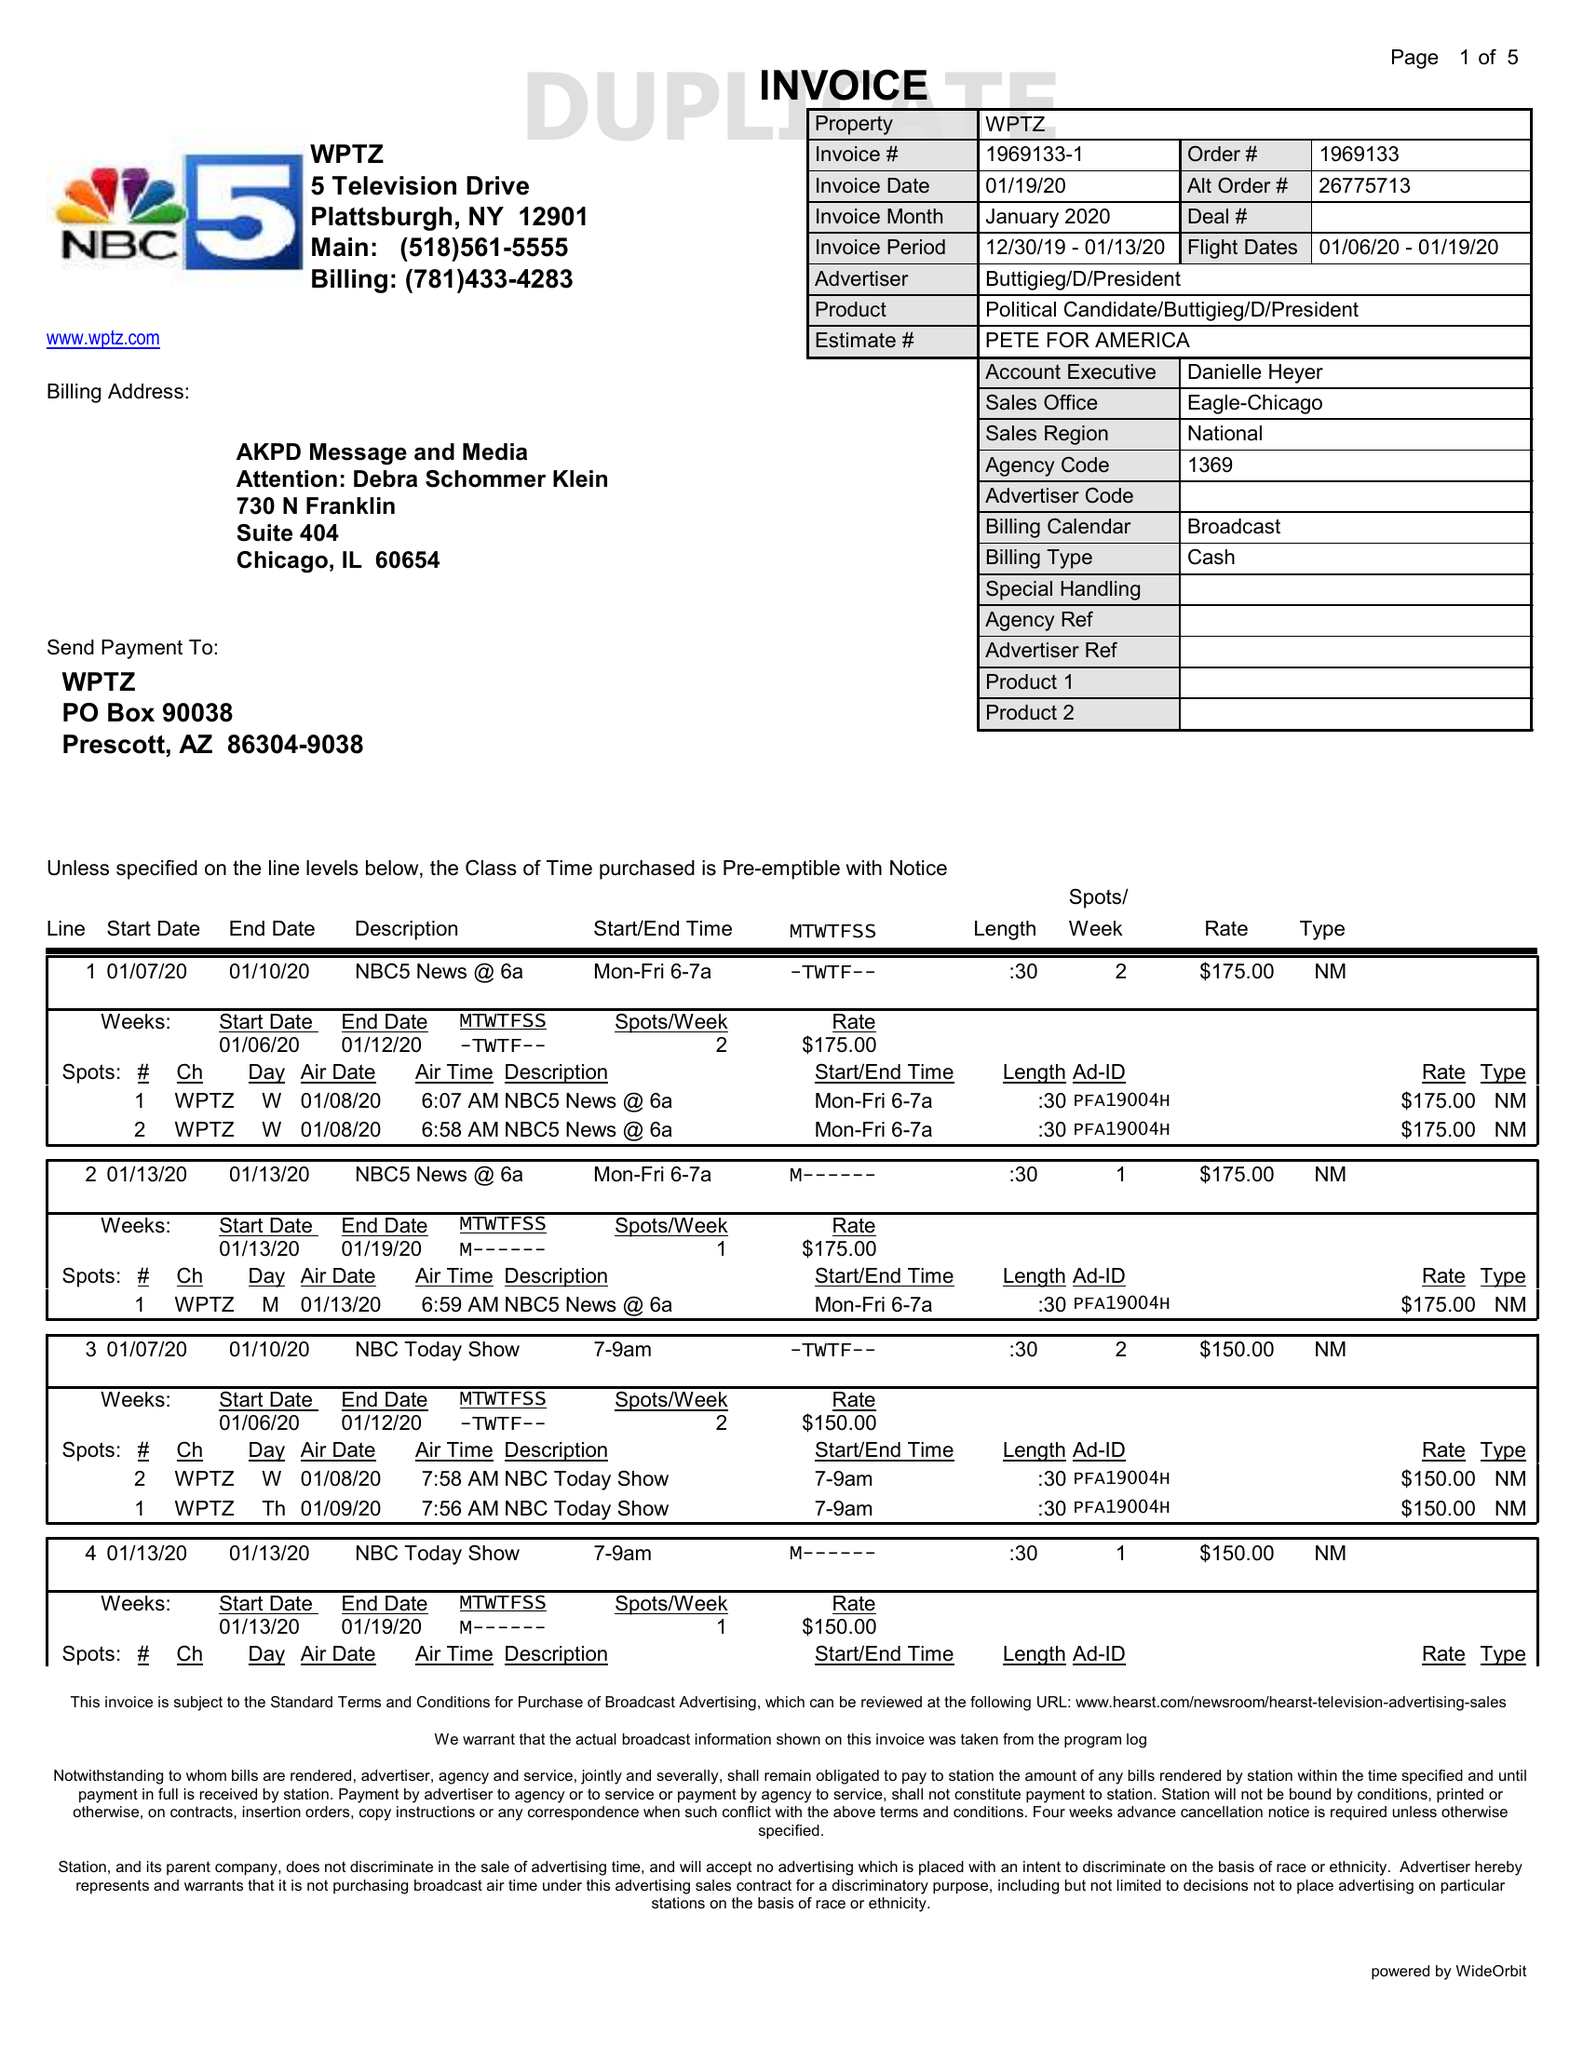What is the value for the contract_num?
Answer the question using a single word or phrase. 1969133 